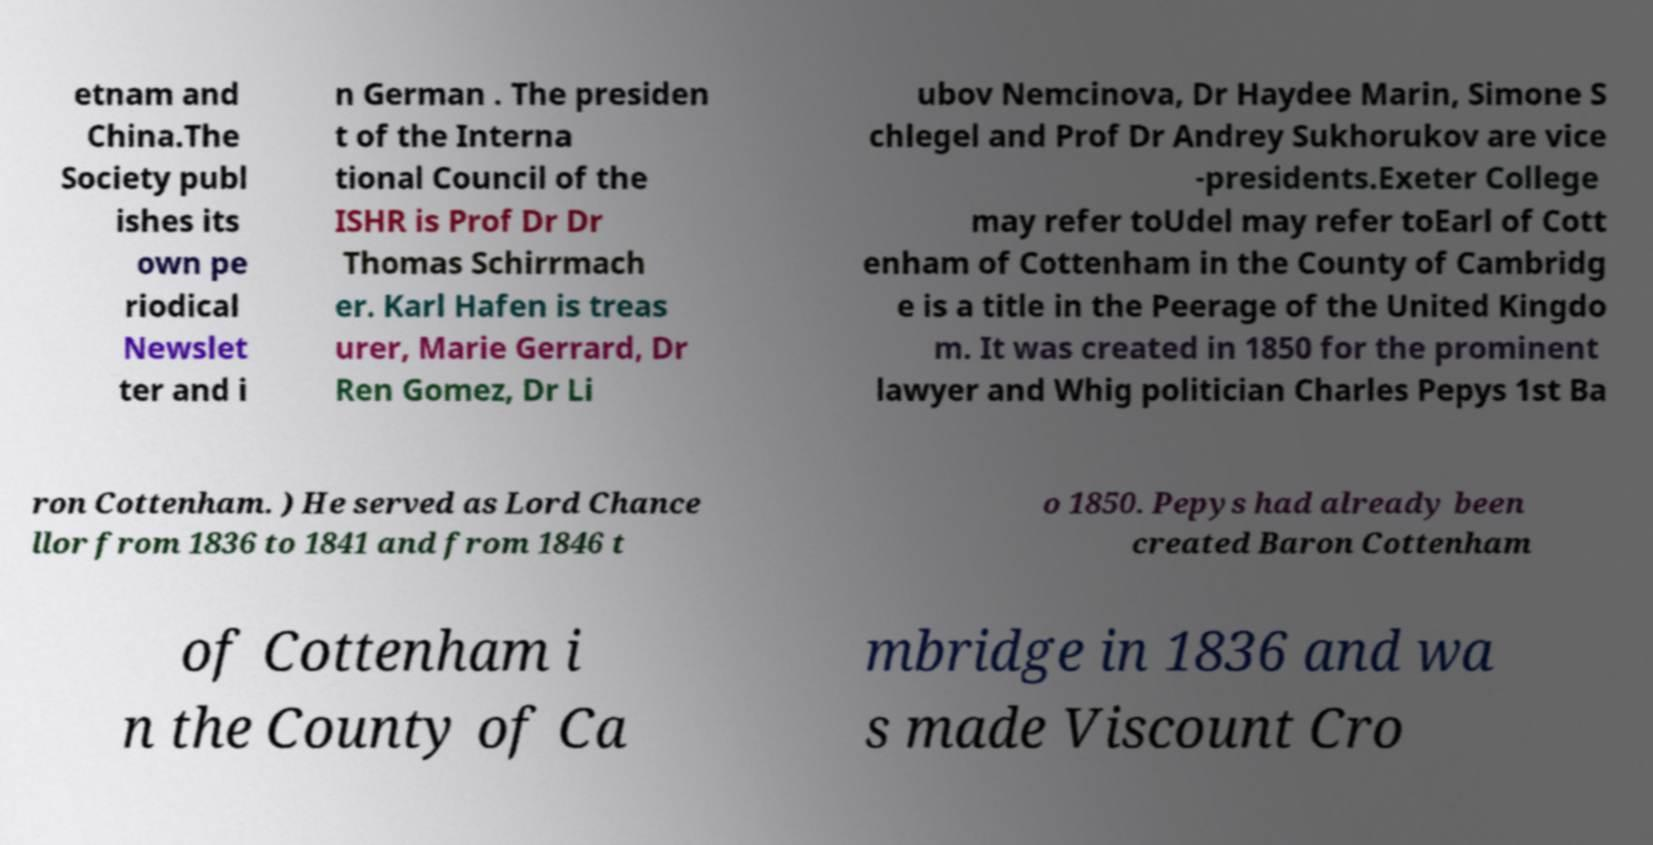Could you extract and type out the text from this image? etnam and China.The Society publ ishes its own pe riodical Newslet ter and i n German . The presiden t of the Interna tional Council of the ISHR is Prof Dr Dr Thomas Schirrmach er. Karl Hafen is treas urer, Marie Gerrard, Dr Ren Gomez, Dr Li ubov Nemcinova, Dr Haydee Marin, Simone S chlegel and Prof Dr Andrey Sukhorukov are vice -presidents.Exeter College may refer toUdel may refer toEarl of Cott enham of Cottenham in the County of Cambridg e is a title in the Peerage of the United Kingdo m. It was created in 1850 for the prominent lawyer and Whig politician Charles Pepys 1st Ba ron Cottenham. ) He served as Lord Chance llor from 1836 to 1841 and from 1846 t o 1850. Pepys had already been created Baron Cottenham of Cottenham i n the County of Ca mbridge in 1836 and wa s made Viscount Cro 